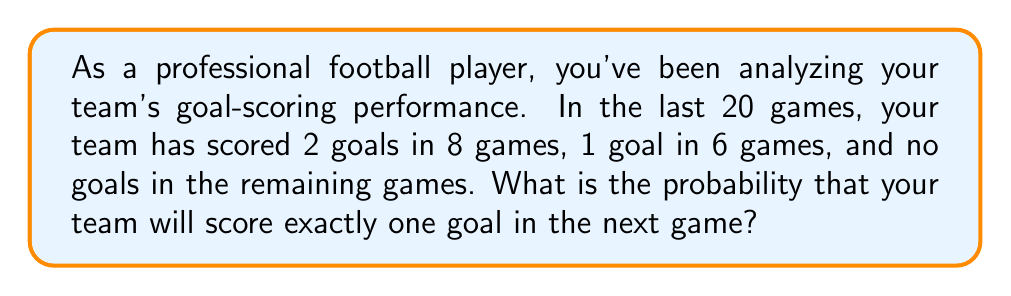Solve this math problem. Let's approach this step-by-step:

1) First, we need to identify the total number of games and the number of games where exactly one goal was scored:
   - Total games: 20
   - Games with exactly one goal: 6

2) In probability theory, when we have a fixed number of independent trials (games in this case) with the same probability of success, we can use the concept of relative frequency to estimate probability.

3) The relative frequency is calculated by dividing the number of favorable outcomes by the total number of trials:

   $$P(\text{exactly one goal}) = \frac{\text{Number of games with one goal}}{\text{Total number of games}}$$

4) Substituting our values:

   $$P(\text{exactly one goal}) = \frac{6}{20}$$

5) Simplify the fraction:

   $$P(\text{exactly one goal}) = \frac{3}{10} = 0.3$$

6) Therefore, based on the historical data, the probability of scoring exactly one goal in the next game is 0.3 or 30%.
Answer: $\frac{3}{10}$ or $0.3$ or $30\%$ 